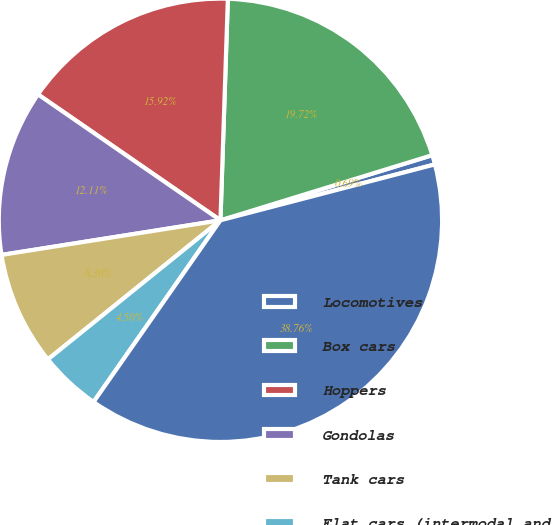Convert chart to OTSL. <chart><loc_0><loc_0><loc_500><loc_500><pie_chart><fcel>Locomotives<fcel>Box cars<fcel>Hoppers<fcel>Gondolas<fcel>Tank cars<fcel>Flat cars (intermodal and<fcel>Total<nl><fcel>0.69%<fcel>19.72%<fcel>15.92%<fcel>12.11%<fcel>8.3%<fcel>4.5%<fcel>38.76%<nl></chart> 